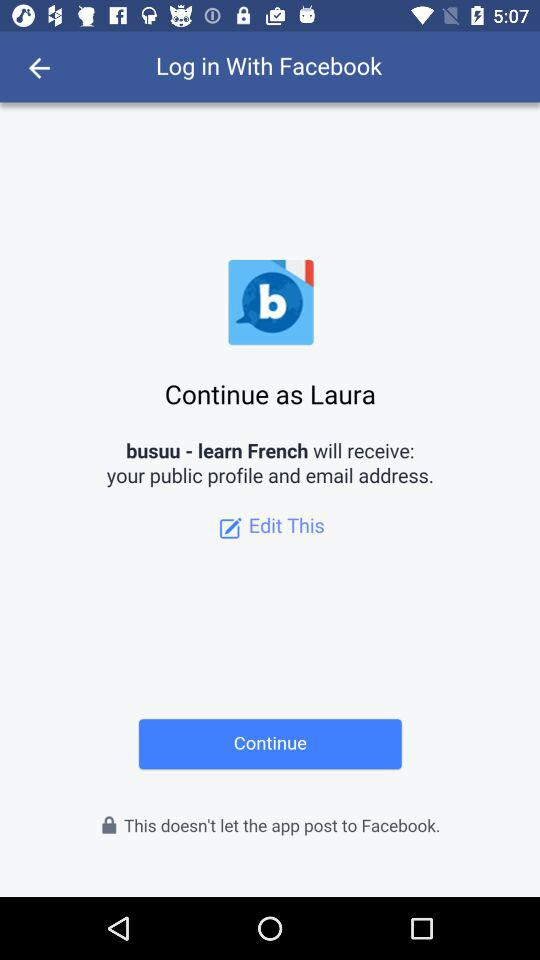What is the user name? The user name is "Laura". 